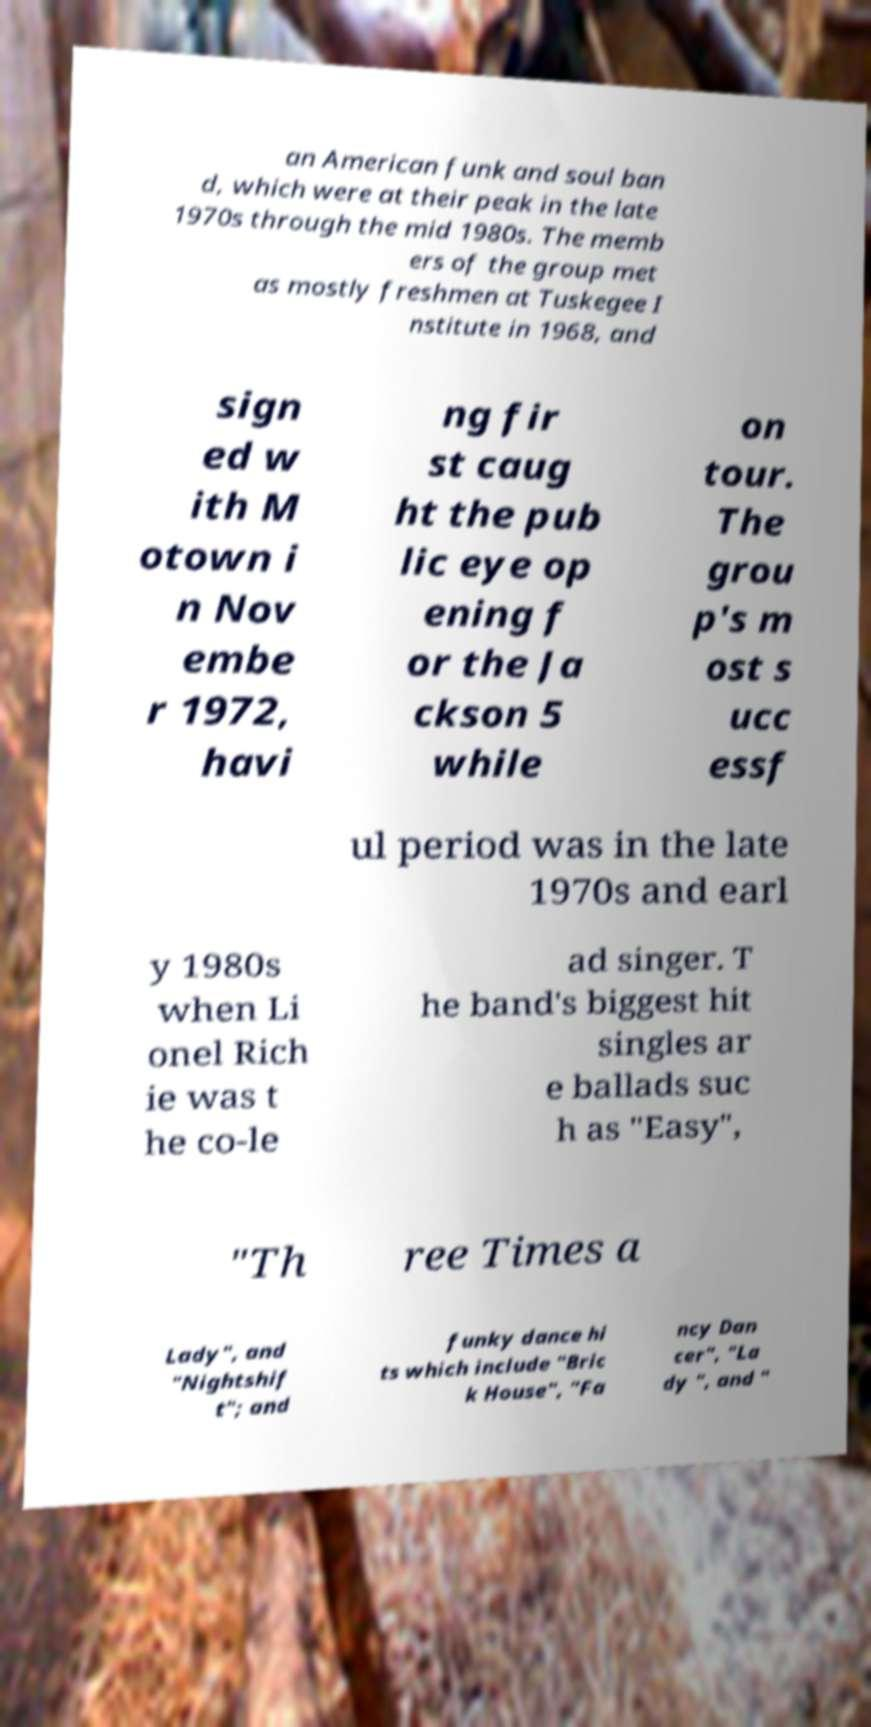Please read and relay the text visible in this image. What does it say? an American funk and soul ban d, which were at their peak in the late 1970s through the mid 1980s. The memb ers of the group met as mostly freshmen at Tuskegee I nstitute in 1968, and sign ed w ith M otown i n Nov embe r 1972, havi ng fir st caug ht the pub lic eye op ening f or the Ja ckson 5 while on tour. The grou p's m ost s ucc essf ul period was in the late 1970s and earl y 1980s when Li onel Rich ie was t he co-le ad singer. T he band's biggest hit singles ar e ballads suc h as "Easy", "Th ree Times a Lady", and "Nightshif t"; and funky dance hi ts which include "Bric k House", "Fa ncy Dan cer", "La dy ", and " 